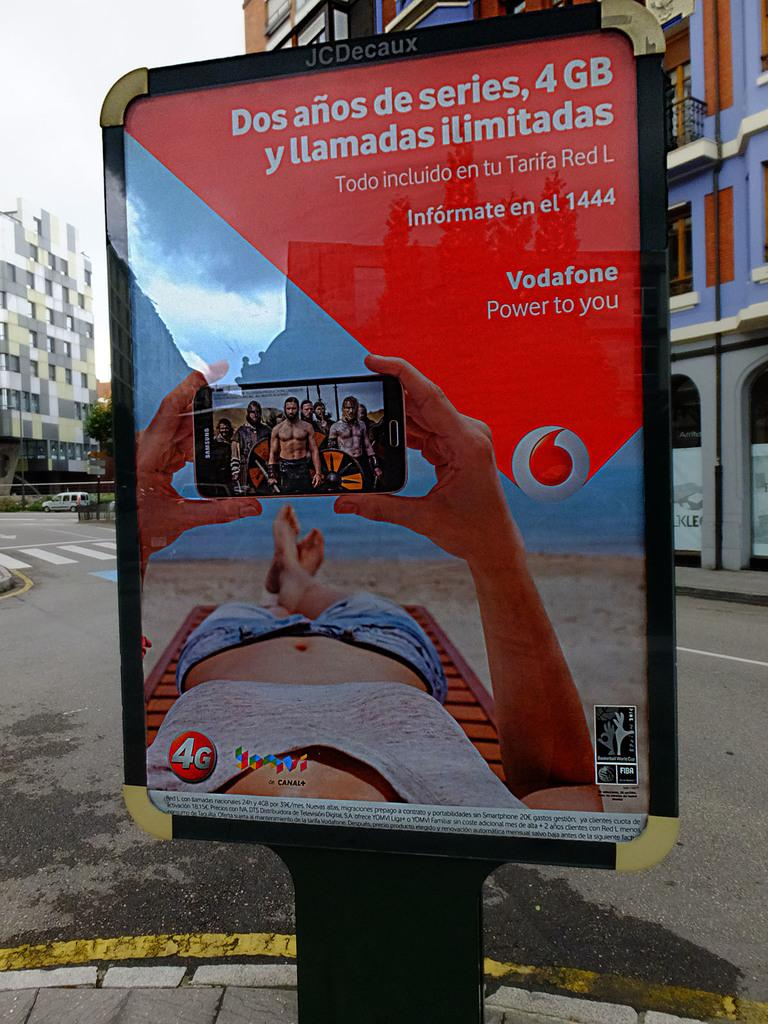What is depicted on the poster in the image? There is a poster with people in the image. What type of structure can be seen in the image? There is a mobile unit in the image. What is moving along the road in the image? There is a vehicle on the road in the image. What type of buildings are visible in the image? There are buildings with windows in the image. What type of vegetation is present in the image? There is a tree in the image. What is visible in the background of the image? The sky is visible in the background of the image. What type of waves can be seen crashing against the buildings in the image? There are no waves present in the image; it features a mobile unit, a vehicle, a tree, and buildings with windows. What type of pest is visible on the poster in the image? There is no pest depicted on the poster in the image; it features people. 